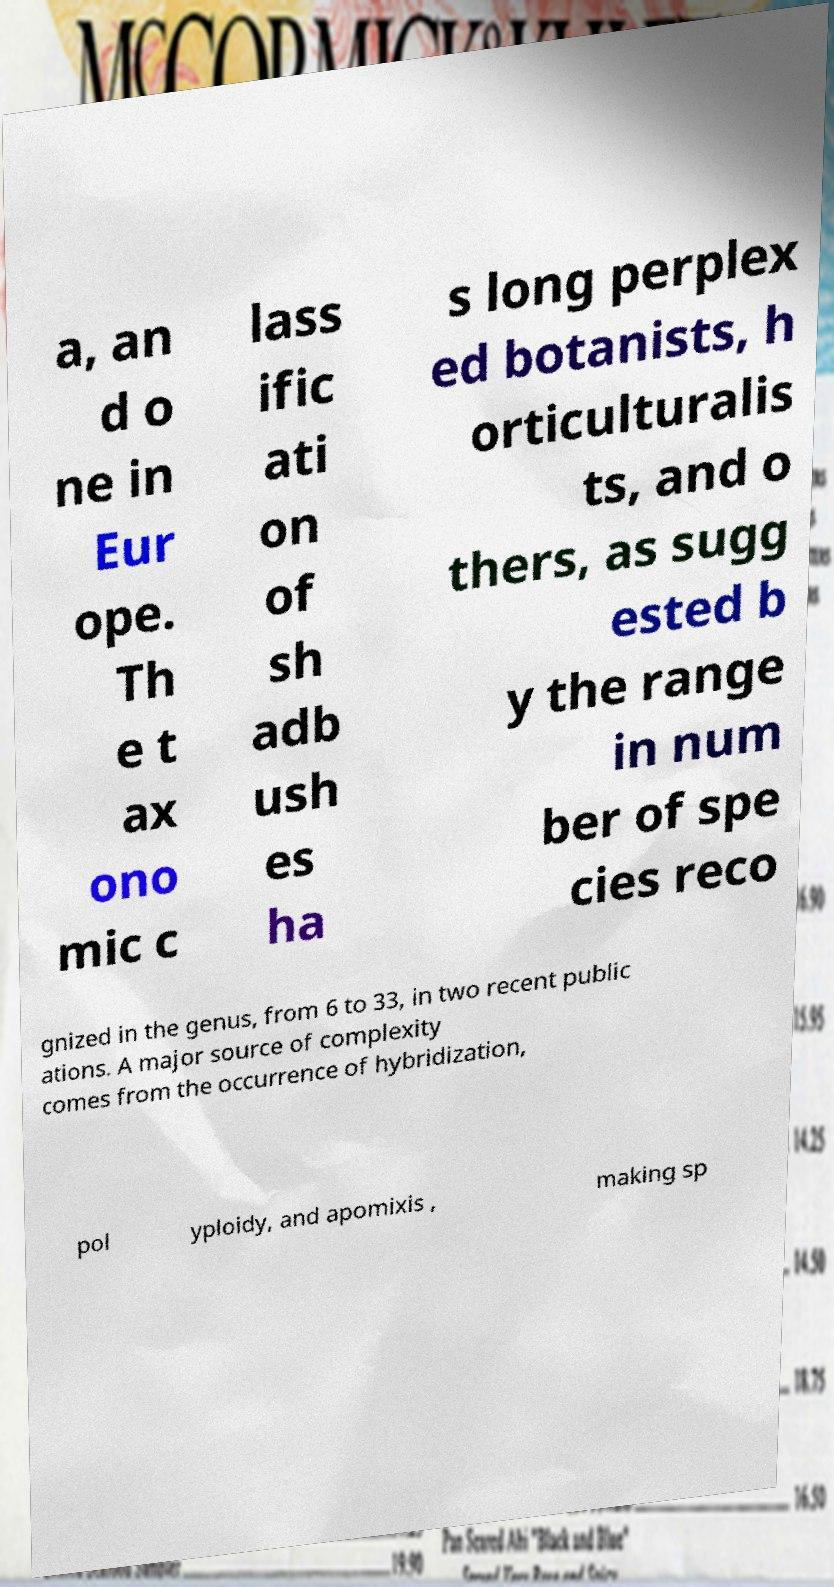What messages or text are displayed in this image? I need them in a readable, typed format. a, an d o ne in Eur ope. Th e t ax ono mic c lass ific ati on of sh adb ush es ha s long perplex ed botanists, h orticulturalis ts, and o thers, as sugg ested b y the range in num ber of spe cies reco gnized in the genus, from 6 to 33, in two recent public ations. A major source of complexity comes from the occurrence of hybridization, pol yploidy, and apomixis , making sp 